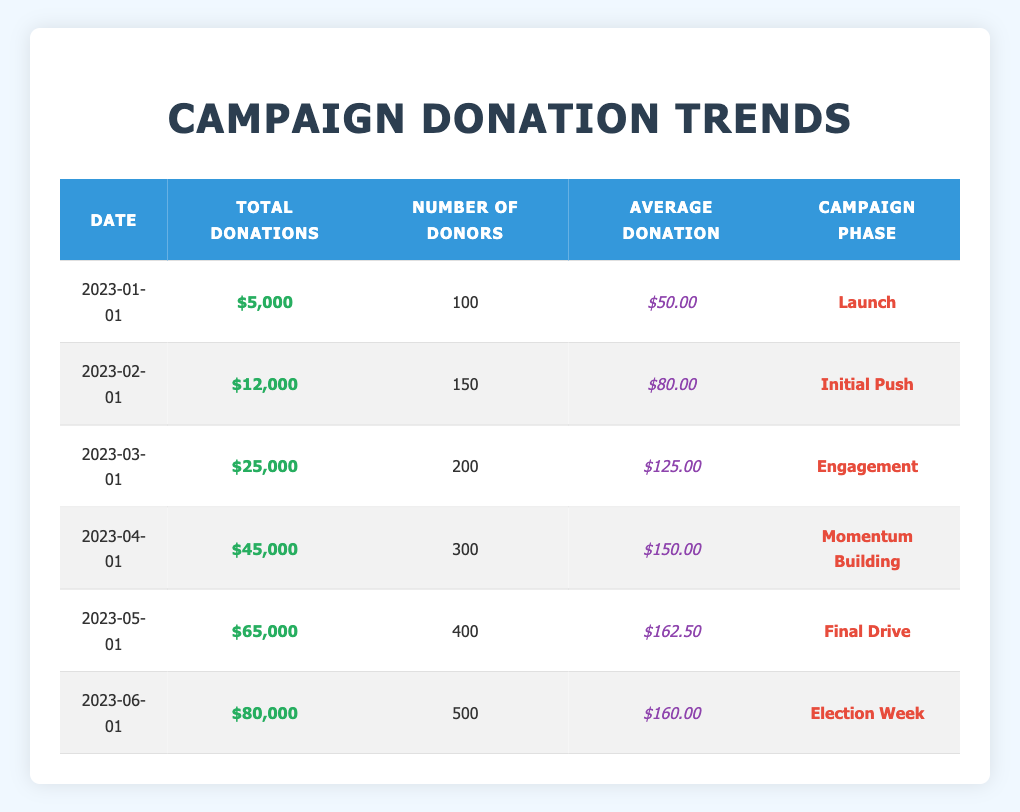What was the total number of donations made during the "Election Week" phase? Referring to the table, under the "Election Week" phase, the total donations listed are $80,000.
Answer: $80,000 Which campaign phase had the highest average donation amount? To determine the highest average donation, I compare the average donation values across all phases. The values are $50.00 (Launch), $80.00 (Initial Push), $125.00 (Engagement), $150.00 (Momentum Building), $162.50 (Final Drive), and $160.00 (Election Week). The highest is $162.50 in the "Final Drive" phase.
Answer: Final Drive How many total donors contributed between the "Launch" and "Initial Push" phases? The number of donors in the "Launch" phase is 100, and in the "Initial Push" phase, it is 150. Adding these gives a total: 100 + 150 = 250 donors contributed in these two phases.
Answer: 250 Is the average donation during the "Final Drive" phase greater than $150? The average donation for the "Final Drive" phase is $162.50, which is greater than $150. Therefore, the answer is Yes.
Answer: Yes What is the percentage increase in total donations from "Engagement" to "Election Week"? To find the percentage increase, I subtract the total donations in "Engagement" ($25,000) from those in "Election Week" ($80,000) to get a difference of $55,000. Then, divide this difference by the original amount: ($55,000 / $25,000) * 100 = 220%.
Answer: 220% 